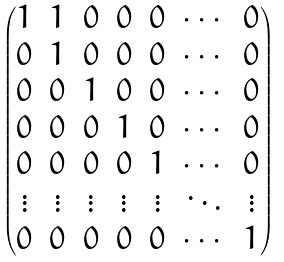<formula> <loc_0><loc_0><loc_500><loc_500>\begin{pmatrix} 1 & 1 & 0 & 0 & 0 & \cdots & 0 \\ 0 & 1 & 0 & 0 & 0 & \cdots & 0 \\ 0 & 0 & 1 & 0 & 0 & \cdots & 0 \\ 0 & 0 & 0 & 1 & 0 & \cdots & 0 \\ 0 & 0 & 0 & 0 & 1 & \cdots & 0 \\ \vdots & \vdots & \vdots & \vdots & \vdots & \ddots & \vdots \\ 0 & 0 & 0 & 0 & 0 & \cdots & 1 \end{pmatrix}</formula> 